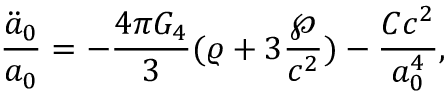Convert formula to latex. <formula><loc_0><loc_0><loc_500><loc_500>{ \frac { \ddot { a } _ { 0 } } { a _ { 0 } } } = - { \frac { 4 \pi G _ { 4 } } { 3 } } ( \varrho + 3 { \frac { \wp } { c ^ { 2 } } } ) - { \frac { C c ^ { 2 } } { a _ { 0 } ^ { 4 } } } ,</formula> 